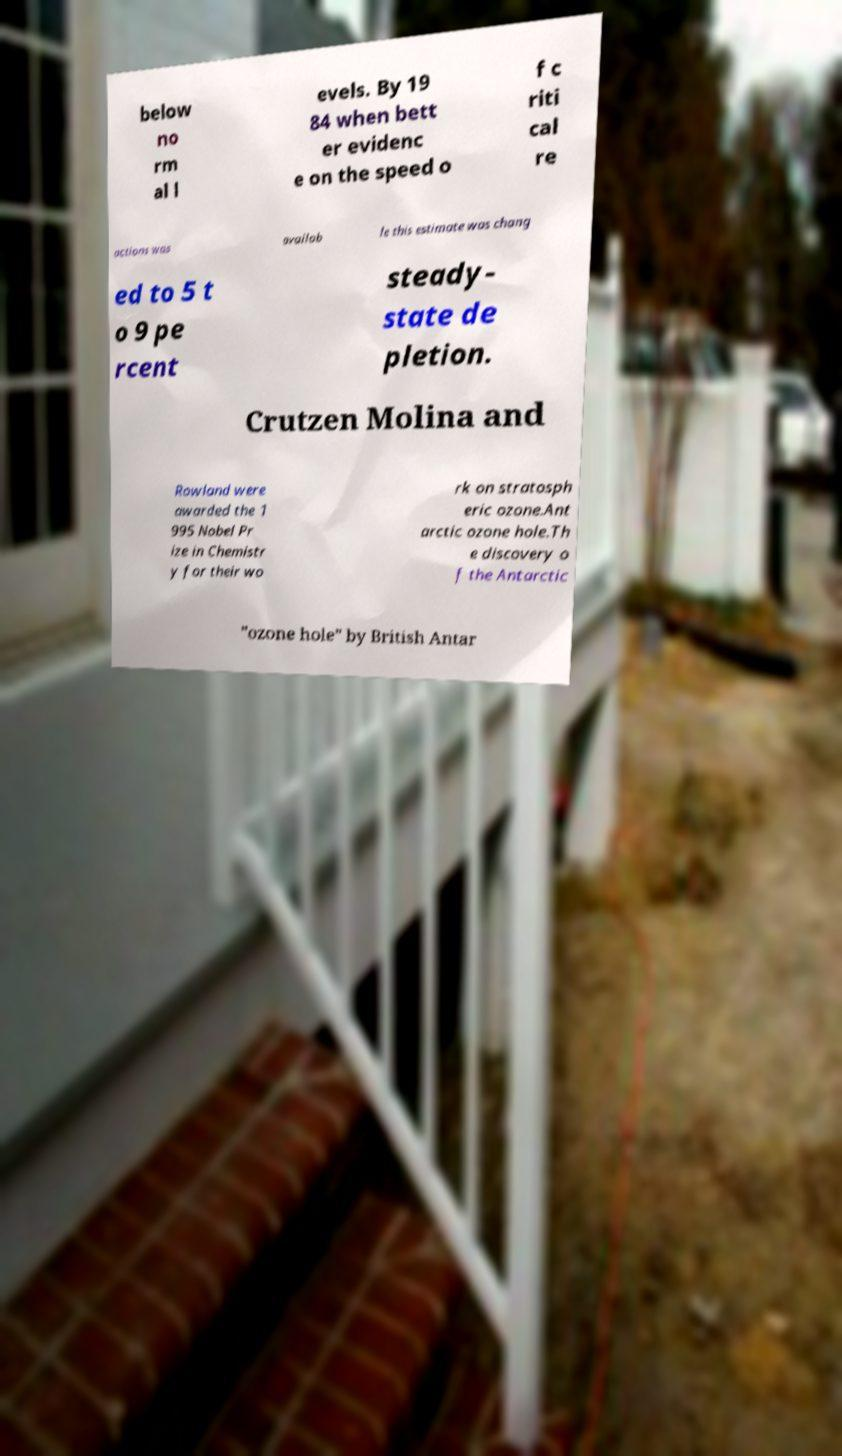Could you assist in decoding the text presented in this image and type it out clearly? below no rm al l evels. By 19 84 when bett er evidenc e on the speed o f c riti cal re actions was availab le this estimate was chang ed to 5 t o 9 pe rcent steady- state de pletion. Crutzen Molina and Rowland were awarded the 1 995 Nobel Pr ize in Chemistr y for their wo rk on stratosph eric ozone.Ant arctic ozone hole.Th e discovery o f the Antarctic "ozone hole" by British Antar 